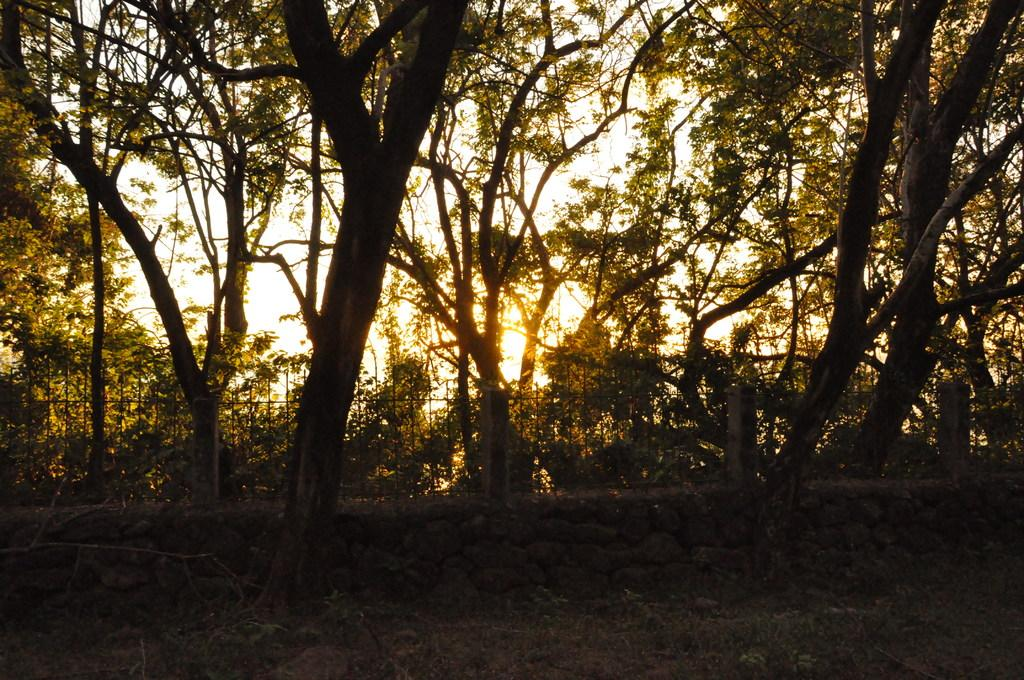What type of vegetation can be seen in the image? There are trees in the image. What is the purpose of the fencing in the image? The purpose of the fencing in the image is not specified, but it could be for enclosing an area or providing a barrier. What is present at the bottom of the image? At the bottom of the image, there are plants and grass. What type of feeling is expressed by the trees in the image? Trees do not express feelings, so this question cannot be answered definitively based on the provided facts. 